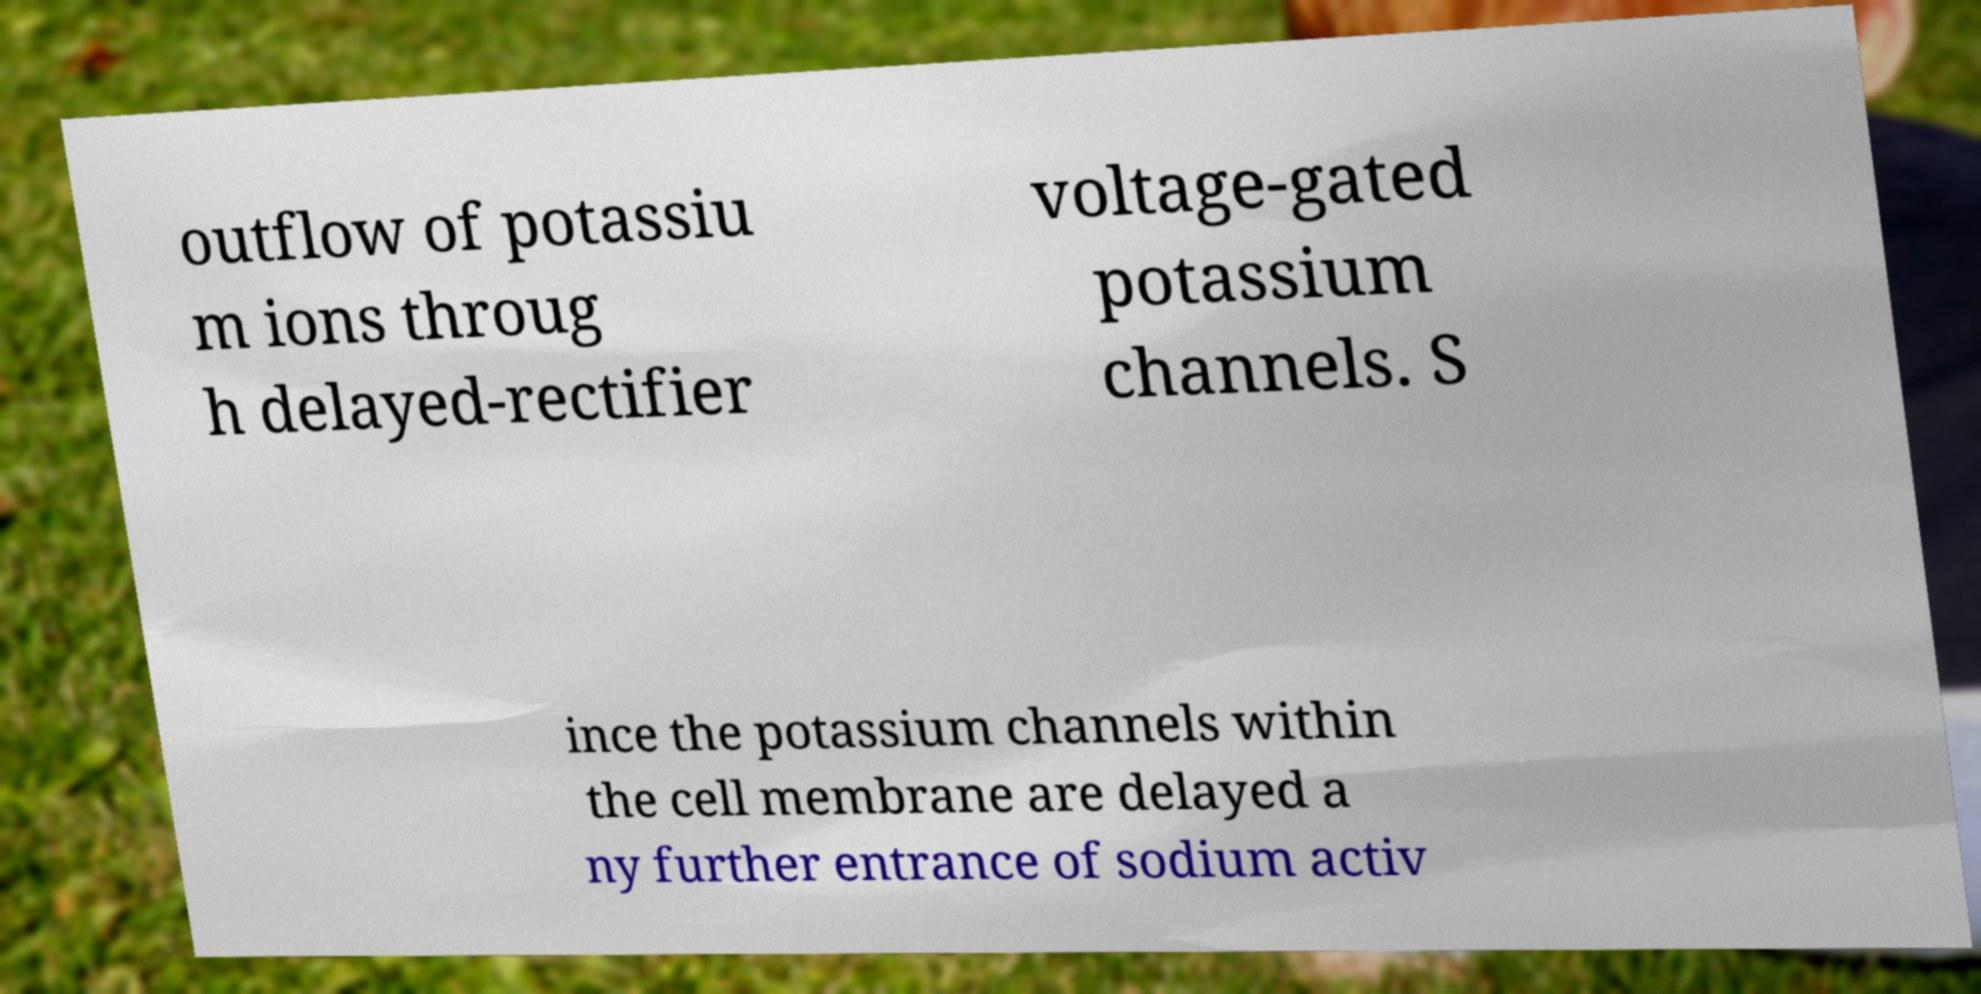Can you read and provide the text displayed in the image?This photo seems to have some interesting text. Can you extract and type it out for me? outflow of potassiu m ions throug h delayed-rectifier voltage-gated potassium channels. S ince the potassium channels within the cell membrane are delayed a ny further entrance of sodium activ 